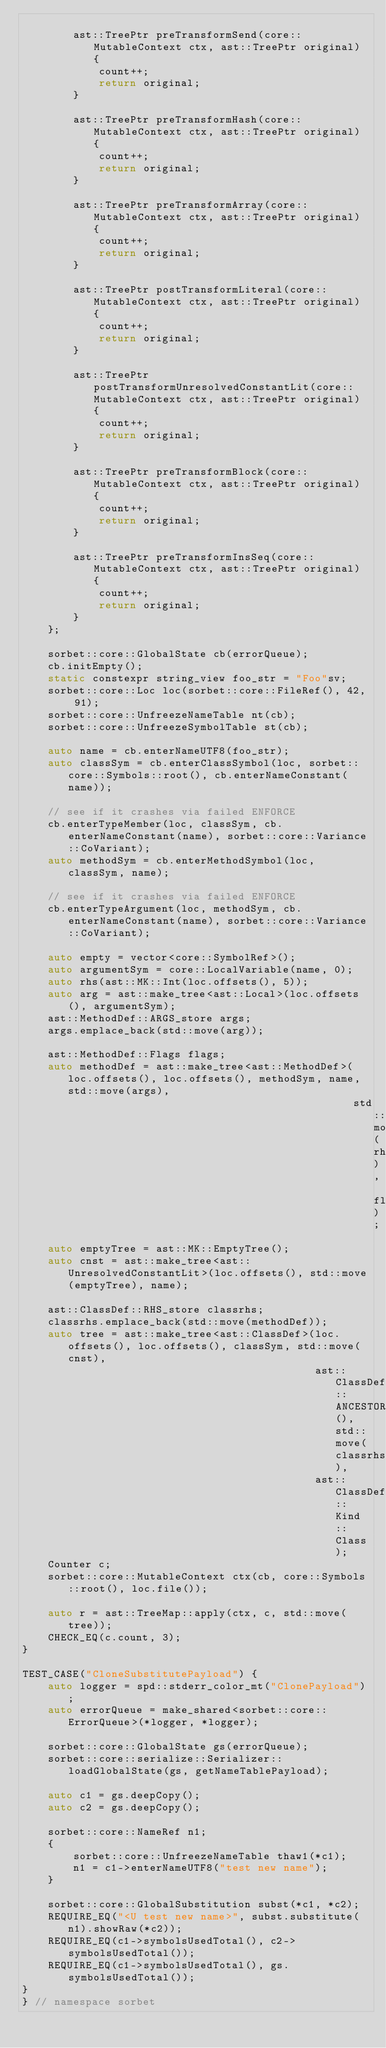Convert code to text. <code><loc_0><loc_0><loc_500><loc_500><_C++_>
        ast::TreePtr preTransformSend(core::MutableContext ctx, ast::TreePtr original) {
            count++;
            return original;
        }

        ast::TreePtr preTransformHash(core::MutableContext ctx, ast::TreePtr original) {
            count++;
            return original;
        }

        ast::TreePtr preTransformArray(core::MutableContext ctx, ast::TreePtr original) {
            count++;
            return original;
        }

        ast::TreePtr postTransformLiteral(core::MutableContext ctx, ast::TreePtr original) {
            count++;
            return original;
        }

        ast::TreePtr postTransformUnresolvedConstantLit(core::MutableContext ctx, ast::TreePtr original) {
            count++;
            return original;
        }

        ast::TreePtr preTransformBlock(core::MutableContext ctx, ast::TreePtr original) {
            count++;
            return original;
        }

        ast::TreePtr preTransformInsSeq(core::MutableContext ctx, ast::TreePtr original) {
            count++;
            return original;
        }
    };

    sorbet::core::GlobalState cb(errorQueue);
    cb.initEmpty();
    static constexpr string_view foo_str = "Foo"sv;
    sorbet::core::Loc loc(sorbet::core::FileRef(), 42, 91);
    sorbet::core::UnfreezeNameTable nt(cb);
    sorbet::core::UnfreezeSymbolTable st(cb);

    auto name = cb.enterNameUTF8(foo_str);
    auto classSym = cb.enterClassSymbol(loc, sorbet::core::Symbols::root(), cb.enterNameConstant(name));

    // see if it crashes via failed ENFORCE
    cb.enterTypeMember(loc, classSym, cb.enterNameConstant(name), sorbet::core::Variance::CoVariant);
    auto methodSym = cb.enterMethodSymbol(loc, classSym, name);

    // see if it crashes via failed ENFORCE
    cb.enterTypeArgument(loc, methodSym, cb.enterNameConstant(name), sorbet::core::Variance::CoVariant);

    auto empty = vector<core::SymbolRef>();
    auto argumentSym = core::LocalVariable(name, 0);
    auto rhs(ast::MK::Int(loc.offsets(), 5));
    auto arg = ast::make_tree<ast::Local>(loc.offsets(), argumentSym);
    ast::MethodDef::ARGS_store args;
    args.emplace_back(std::move(arg));

    ast::MethodDef::Flags flags;
    auto methodDef = ast::make_tree<ast::MethodDef>(loc.offsets(), loc.offsets(), methodSym, name, std::move(args),
                                                    std::move(rhs), flags);
    auto emptyTree = ast::MK::EmptyTree();
    auto cnst = ast::make_tree<ast::UnresolvedConstantLit>(loc.offsets(), std::move(emptyTree), name);

    ast::ClassDef::RHS_store classrhs;
    classrhs.emplace_back(std::move(methodDef));
    auto tree = ast::make_tree<ast::ClassDef>(loc.offsets(), loc.offsets(), classSym, std::move(cnst),
                                              ast::ClassDef::ANCESTORS_store(), std::move(classrhs),
                                              ast::ClassDef::Kind::Class);
    Counter c;
    sorbet::core::MutableContext ctx(cb, core::Symbols::root(), loc.file());

    auto r = ast::TreeMap::apply(ctx, c, std::move(tree));
    CHECK_EQ(c.count, 3);
}

TEST_CASE("CloneSubstitutePayload") {
    auto logger = spd::stderr_color_mt("ClonePayload");
    auto errorQueue = make_shared<sorbet::core::ErrorQueue>(*logger, *logger);

    sorbet::core::GlobalState gs(errorQueue);
    sorbet::core::serialize::Serializer::loadGlobalState(gs, getNameTablePayload);

    auto c1 = gs.deepCopy();
    auto c2 = gs.deepCopy();

    sorbet::core::NameRef n1;
    {
        sorbet::core::UnfreezeNameTable thaw1(*c1);
        n1 = c1->enterNameUTF8("test new name");
    }

    sorbet::core::GlobalSubstitution subst(*c1, *c2);
    REQUIRE_EQ("<U test new name>", subst.substitute(n1).showRaw(*c2));
    REQUIRE_EQ(c1->symbolsUsedTotal(), c2->symbolsUsedTotal());
    REQUIRE_EQ(c1->symbolsUsedTotal(), gs.symbolsUsedTotal());
}
} // namespace sorbet
</code> 